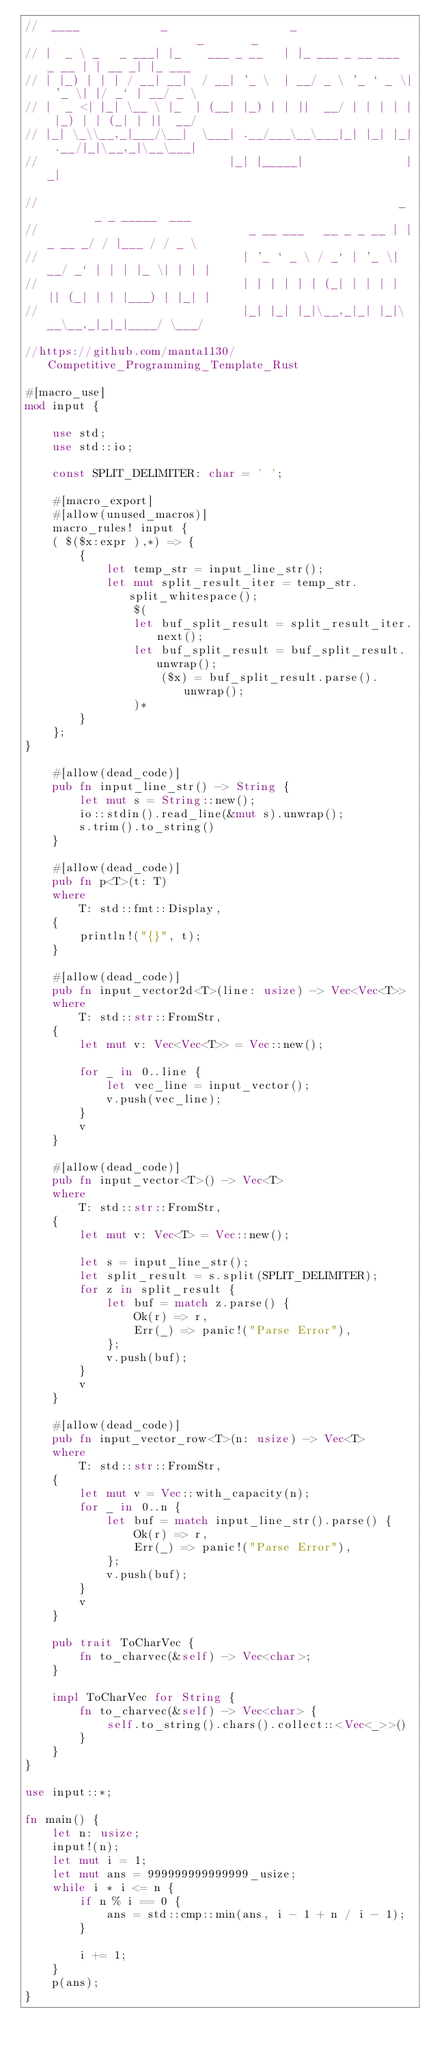<code> <loc_0><loc_0><loc_500><loc_500><_Rust_>//  ____            _                  _                       _       _
// |  _ \ _   _ ___| |_    ___ _ __   | |_ ___ _ __ ___  _ __ | | __ _| |_ ___
// | |_) | | | / __| __|  / __| '_ \  | __/ _ \ '_ ` _ \| '_ \| |/ _` | __/ _ \
// |  _ <| |_| \__ \ |_  | (__| |_) | | ||  __/ | | | | | |_) | | (_| | ||  __/
// |_| \_\\__,_|___/\__|  \___| .__/___\__\___|_| |_| |_| .__/|_|\__,_|\__\___|
//                            |_| |_____|               |_|

//                                                     _        _ _ _____  ___
//                               _ __ ___   __ _ _ __ | |_ __ _/ / |___ / / _ \
//                              | '_ ` _ \ / _` | '_ \| __/ _` | | | |_ \| | | |
//                              | | | | | | (_| | | | | || (_| | | |___) | |_| |
//                              |_| |_| |_|\__,_|_| |_|\__\__,_|_|_|____/ \___/

//https://github.com/manta1130/Competitive_Programming_Template_Rust

#[macro_use]
mod input {

    use std;
    use std::io;

    const SPLIT_DELIMITER: char = ' ';

    #[macro_export]
    #[allow(unused_macros)]
    macro_rules! input {
    ( $($x:expr ),*) => {
        {
            let temp_str = input_line_str();
            let mut split_result_iter = temp_str.split_whitespace();
                $(
                let buf_split_result = split_result_iter.next();
                let buf_split_result = buf_split_result.unwrap();
                    ($x) = buf_split_result.parse().unwrap();
                )*
        }
    };
}

    #[allow(dead_code)]
    pub fn input_line_str() -> String {
        let mut s = String::new();
        io::stdin().read_line(&mut s).unwrap();
        s.trim().to_string()
    }

    #[allow(dead_code)]
    pub fn p<T>(t: T)
    where
        T: std::fmt::Display,
    {
        println!("{}", t);
    }

    #[allow(dead_code)]
    pub fn input_vector2d<T>(line: usize) -> Vec<Vec<T>>
    where
        T: std::str::FromStr,
    {
        let mut v: Vec<Vec<T>> = Vec::new();

        for _ in 0..line {
            let vec_line = input_vector();
            v.push(vec_line);
        }
        v
    }

    #[allow(dead_code)]
    pub fn input_vector<T>() -> Vec<T>
    where
        T: std::str::FromStr,
    {
        let mut v: Vec<T> = Vec::new();

        let s = input_line_str();
        let split_result = s.split(SPLIT_DELIMITER);
        for z in split_result {
            let buf = match z.parse() {
                Ok(r) => r,
                Err(_) => panic!("Parse Error"),
            };
            v.push(buf);
        }
        v
    }

    #[allow(dead_code)]
    pub fn input_vector_row<T>(n: usize) -> Vec<T>
    where
        T: std::str::FromStr,
    {
        let mut v = Vec::with_capacity(n);
        for _ in 0..n {
            let buf = match input_line_str().parse() {
                Ok(r) => r,
                Err(_) => panic!("Parse Error"),
            };
            v.push(buf);
        }
        v
    }

    pub trait ToCharVec {
        fn to_charvec(&self) -> Vec<char>;
    }

    impl ToCharVec for String {
        fn to_charvec(&self) -> Vec<char> {
            self.to_string().chars().collect::<Vec<_>>()
        }
    }
}

use input::*;

fn main() {
    let n: usize;
    input!(n);
    let mut i = 1;
    let mut ans = 999999999999999_usize;
    while i * i <= n {
        if n % i == 0 {
            ans = std::cmp::min(ans, i - 1 + n / i - 1);
        }

        i += 1;
    }
    p(ans);
}
</code> 